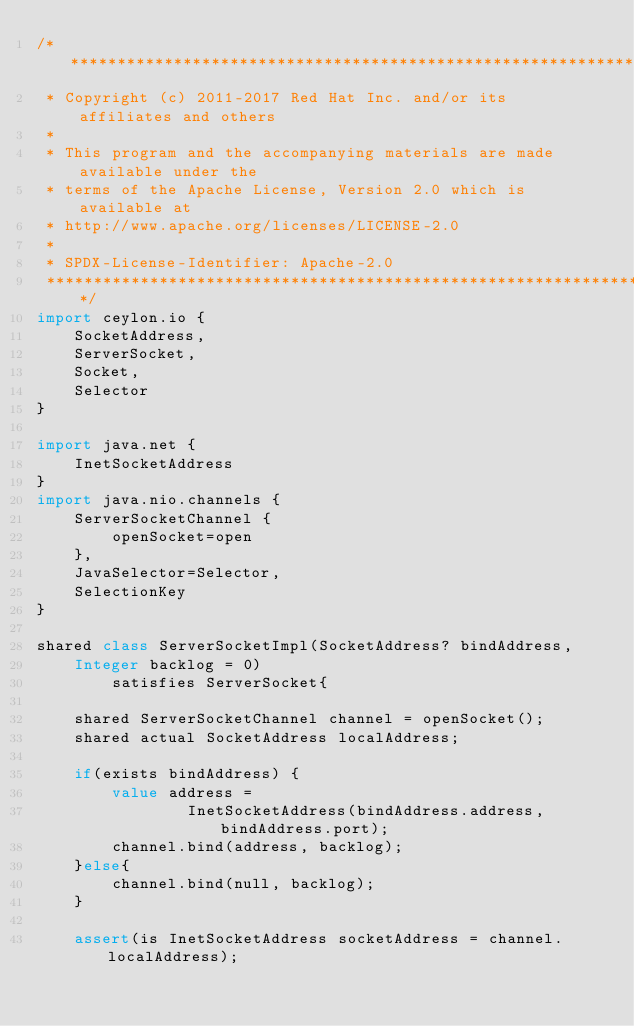<code> <loc_0><loc_0><loc_500><loc_500><_Ceylon_>/********************************************************************************
 * Copyright (c) 2011-2017 Red Hat Inc. and/or its affiliates and others
 *
 * This program and the accompanying materials are made available under the 
 * terms of the Apache License, Version 2.0 which is available at
 * http://www.apache.org/licenses/LICENSE-2.0
 *
 * SPDX-License-Identifier: Apache-2.0 
 ********************************************************************************/
import ceylon.io {
    SocketAddress,
    ServerSocket,
    Socket,
    Selector
}

import java.net {
    InetSocketAddress
}
import java.nio.channels {
    ServerSocketChannel {
        openSocket=open
    },
    JavaSelector=Selector,
    SelectionKey
}

shared class ServerSocketImpl(SocketAddress? bindAddress, 
    Integer backlog = 0) 
        satisfies ServerSocket{

    shared ServerSocketChannel channel = openSocket();
    shared actual SocketAddress localAddress;

    if(exists bindAddress) {
        value address = 
                InetSocketAddress(bindAddress.address, bindAddress.port);
        channel.bind(address, backlog);
    }else{
        channel.bind(null, backlog);
    }

    assert(is InetSocketAddress socketAddress = channel.localAddress);</code> 